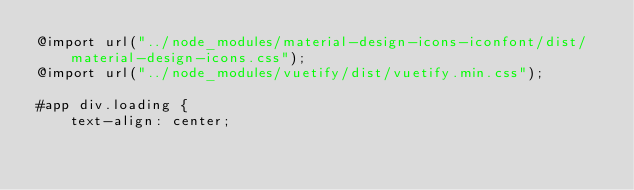Convert code to text. <code><loc_0><loc_0><loc_500><loc_500><_CSS_>@import url("../node_modules/material-design-icons-iconfont/dist/material-design-icons.css");
@import url("../node_modules/vuetify/dist/vuetify.min.css");

#app div.loading {
    text-align: center;</code> 